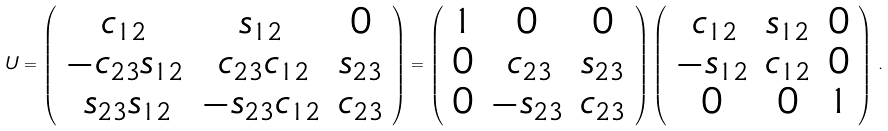Convert formula to latex. <formula><loc_0><loc_0><loc_500><loc_500>U = \left ( \begin{array} { c c c } c _ { 1 2 } & s _ { 1 2 } & 0 \\ - c _ { 2 3 } s _ { 1 2 } & \, c _ { 2 3 } c _ { 1 2 } & s _ { 2 3 } \\ \, s _ { 2 3 } s _ { 1 2 } & - s _ { 2 3 } c _ { 1 2 } & c _ { 2 3 } \end{array} \right ) = \left ( \begin{array} { c c c } 1 & 0 & 0 \\ 0 & \, c _ { 2 3 } & s _ { 2 3 } \\ 0 & - s _ { 2 3 } & c _ { 2 3 } \end{array} \right ) \left ( \begin{array} { c c c } \, c _ { 1 2 } & s _ { 1 2 } & 0 \\ - s _ { 1 2 } & c _ { 1 2 } & 0 \\ 0 & 0 & 1 \end{array} \right ) \, .</formula> 